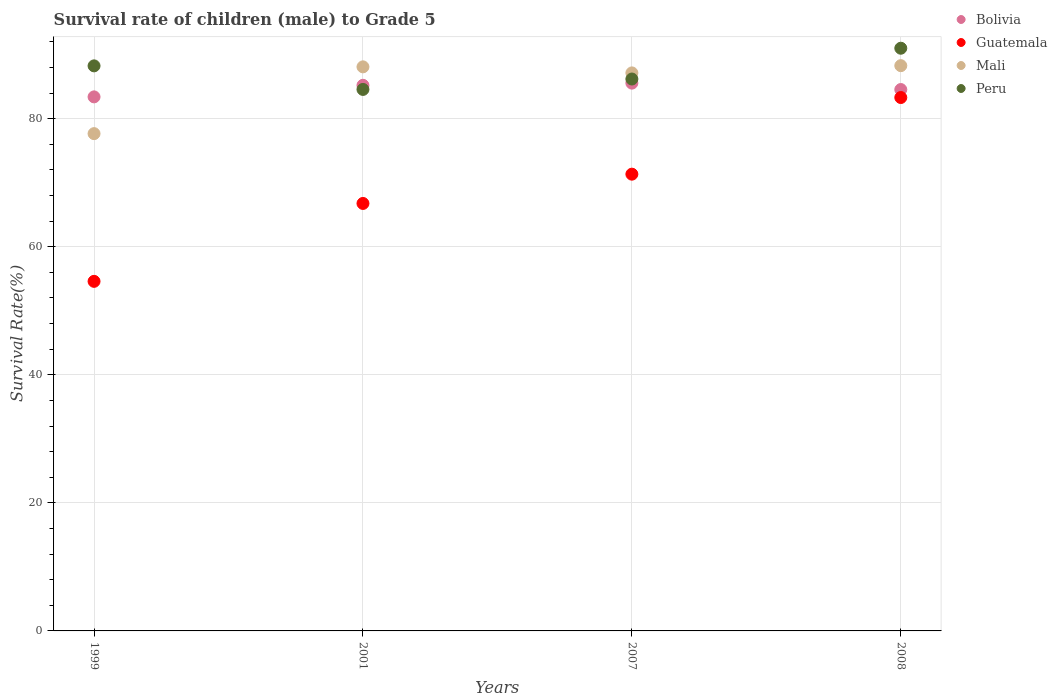Is the number of dotlines equal to the number of legend labels?
Offer a very short reply. Yes. What is the survival rate of male children to grade 5 in Mali in 2007?
Offer a terse response. 87.15. Across all years, what is the maximum survival rate of male children to grade 5 in Mali?
Keep it short and to the point. 88.28. Across all years, what is the minimum survival rate of male children to grade 5 in Mali?
Your answer should be very brief. 77.66. In which year was the survival rate of male children to grade 5 in Guatemala maximum?
Ensure brevity in your answer.  2008. In which year was the survival rate of male children to grade 5 in Mali minimum?
Give a very brief answer. 1999. What is the total survival rate of male children to grade 5 in Peru in the graph?
Provide a succinct answer. 350. What is the difference between the survival rate of male children to grade 5 in Bolivia in 2007 and that in 2008?
Your response must be concise. 1. What is the difference between the survival rate of male children to grade 5 in Bolivia in 2001 and the survival rate of male children to grade 5 in Peru in 2008?
Offer a terse response. -5.79. What is the average survival rate of male children to grade 5 in Mali per year?
Provide a succinct answer. 85.29. In the year 2001, what is the difference between the survival rate of male children to grade 5 in Guatemala and survival rate of male children to grade 5 in Peru?
Provide a short and direct response. -17.8. What is the ratio of the survival rate of male children to grade 5 in Peru in 1999 to that in 2007?
Make the answer very short. 1.02. Is the survival rate of male children to grade 5 in Bolivia in 1999 less than that in 2007?
Keep it short and to the point. Yes. Is the difference between the survival rate of male children to grade 5 in Guatemala in 2001 and 2008 greater than the difference between the survival rate of male children to grade 5 in Peru in 2001 and 2008?
Keep it short and to the point. No. What is the difference between the highest and the second highest survival rate of male children to grade 5 in Guatemala?
Provide a succinct answer. 11.97. What is the difference between the highest and the lowest survival rate of male children to grade 5 in Guatemala?
Offer a terse response. 28.71. Is the sum of the survival rate of male children to grade 5 in Guatemala in 2007 and 2008 greater than the maximum survival rate of male children to grade 5 in Mali across all years?
Give a very brief answer. Yes. Is it the case that in every year, the sum of the survival rate of male children to grade 5 in Guatemala and survival rate of male children to grade 5 in Mali  is greater than the sum of survival rate of male children to grade 5 in Bolivia and survival rate of male children to grade 5 in Peru?
Your answer should be very brief. No. Does the survival rate of male children to grade 5 in Bolivia monotonically increase over the years?
Keep it short and to the point. No. Is the survival rate of male children to grade 5 in Peru strictly greater than the survival rate of male children to grade 5 in Bolivia over the years?
Provide a short and direct response. No. Is the survival rate of male children to grade 5 in Bolivia strictly less than the survival rate of male children to grade 5 in Mali over the years?
Provide a succinct answer. No. How many dotlines are there?
Your answer should be compact. 4. Does the graph contain any zero values?
Offer a very short reply. No. How are the legend labels stacked?
Your answer should be very brief. Vertical. What is the title of the graph?
Your answer should be compact. Survival rate of children (male) to Grade 5. What is the label or title of the X-axis?
Make the answer very short. Years. What is the label or title of the Y-axis?
Your response must be concise. Survival Rate(%). What is the Survival Rate(%) in Bolivia in 1999?
Make the answer very short. 83.4. What is the Survival Rate(%) in Guatemala in 1999?
Ensure brevity in your answer.  54.59. What is the Survival Rate(%) of Mali in 1999?
Provide a succinct answer. 77.66. What is the Survival Rate(%) of Peru in 1999?
Provide a short and direct response. 88.24. What is the Survival Rate(%) of Bolivia in 2001?
Your response must be concise. 85.21. What is the Survival Rate(%) of Guatemala in 2001?
Offer a terse response. 66.76. What is the Survival Rate(%) of Mali in 2001?
Offer a very short reply. 88.09. What is the Survival Rate(%) of Peru in 2001?
Keep it short and to the point. 84.56. What is the Survival Rate(%) in Bolivia in 2007?
Give a very brief answer. 85.55. What is the Survival Rate(%) of Guatemala in 2007?
Your response must be concise. 71.33. What is the Survival Rate(%) of Mali in 2007?
Your answer should be very brief. 87.15. What is the Survival Rate(%) in Peru in 2007?
Offer a terse response. 86.19. What is the Survival Rate(%) of Bolivia in 2008?
Your response must be concise. 84.55. What is the Survival Rate(%) of Guatemala in 2008?
Ensure brevity in your answer.  83.3. What is the Survival Rate(%) of Mali in 2008?
Your answer should be very brief. 88.28. What is the Survival Rate(%) in Peru in 2008?
Ensure brevity in your answer.  91. Across all years, what is the maximum Survival Rate(%) of Bolivia?
Make the answer very short. 85.55. Across all years, what is the maximum Survival Rate(%) of Guatemala?
Your response must be concise. 83.3. Across all years, what is the maximum Survival Rate(%) of Mali?
Your answer should be compact. 88.28. Across all years, what is the maximum Survival Rate(%) in Peru?
Your answer should be compact. 91. Across all years, what is the minimum Survival Rate(%) of Bolivia?
Make the answer very short. 83.4. Across all years, what is the minimum Survival Rate(%) in Guatemala?
Offer a very short reply. 54.59. Across all years, what is the minimum Survival Rate(%) of Mali?
Make the answer very short. 77.66. Across all years, what is the minimum Survival Rate(%) in Peru?
Keep it short and to the point. 84.56. What is the total Survival Rate(%) of Bolivia in the graph?
Provide a succinct answer. 338.71. What is the total Survival Rate(%) of Guatemala in the graph?
Your answer should be very brief. 275.98. What is the total Survival Rate(%) in Mali in the graph?
Provide a short and direct response. 341.17. What is the total Survival Rate(%) of Peru in the graph?
Keep it short and to the point. 350. What is the difference between the Survival Rate(%) of Bolivia in 1999 and that in 2001?
Provide a short and direct response. -1.81. What is the difference between the Survival Rate(%) in Guatemala in 1999 and that in 2001?
Provide a succinct answer. -12.17. What is the difference between the Survival Rate(%) of Mali in 1999 and that in 2001?
Offer a terse response. -10.43. What is the difference between the Survival Rate(%) of Peru in 1999 and that in 2001?
Your answer should be compact. 3.68. What is the difference between the Survival Rate(%) in Bolivia in 1999 and that in 2007?
Make the answer very short. -2.15. What is the difference between the Survival Rate(%) of Guatemala in 1999 and that in 2007?
Offer a very short reply. -16.74. What is the difference between the Survival Rate(%) of Mali in 1999 and that in 2007?
Make the answer very short. -9.48. What is the difference between the Survival Rate(%) in Peru in 1999 and that in 2007?
Provide a short and direct response. 2.05. What is the difference between the Survival Rate(%) of Bolivia in 1999 and that in 2008?
Offer a terse response. -1.15. What is the difference between the Survival Rate(%) of Guatemala in 1999 and that in 2008?
Provide a succinct answer. -28.71. What is the difference between the Survival Rate(%) in Mali in 1999 and that in 2008?
Provide a short and direct response. -10.61. What is the difference between the Survival Rate(%) of Peru in 1999 and that in 2008?
Provide a succinct answer. -2.75. What is the difference between the Survival Rate(%) in Bolivia in 2001 and that in 2007?
Provide a short and direct response. -0.34. What is the difference between the Survival Rate(%) in Guatemala in 2001 and that in 2007?
Your answer should be compact. -4.57. What is the difference between the Survival Rate(%) of Mali in 2001 and that in 2007?
Ensure brevity in your answer.  0.94. What is the difference between the Survival Rate(%) in Peru in 2001 and that in 2007?
Give a very brief answer. -1.63. What is the difference between the Survival Rate(%) in Bolivia in 2001 and that in 2008?
Provide a succinct answer. 0.66. What is the difference between the Survival Rate(%) in Guatemala in 2001 and that in 2008?
Give a very brief answer. -16.54. What is the difference between the Survival Rate(%) in Mali in 2001 and that in 2008?
Your answer should be compact. -0.19. What is the difference between the Survival Rate(%) of Peru in 2001 and that in 2008?
Make the answer very short. -6.43. What is the difference between the Survival Rate(%) in Guatemala in 2007 and that in 2008?
Provide a short and direct response. -11.97. What is the difference between the Survival Rate(%) of Mali in 2007 and that in 2008?
Provide a short and direct response. -1.13. What is the difference between the Survival Rate(%) in Peru in 2007 and that in 2008?
Provide a short and direct response. -4.81. What is the difference between the Survival Rate(%) of Bolivia in 1999 and the Survival Rate(%) of Guatemala in 2001?
Your answer should be compact. 16.64. What is the difference between the Survival Rate(%) of Bolivia in 1999 and the Survival Rate(%) of Mali in 2001?
Your response must be concise. -4.69. What is the difference between the Survival Rate(%) of Bolivia in 1999 and the Survival Rate(%) of Peru in 2001?
Offer a very short reply. -1.16. What is the difference between the Survival Rate(%) of Guatemala in 1999 and the Survival Rate(%) of Mali in 2001?
Ensure brevity in your answer.  -33.5. What is the difference between the Survival Rate(%) of Guatemala in 1999 and the Survival Rate(%) of Peru in 2001?
Offer a terse response. -29.97. What is the difference between the Survival Rate(%) in Mali in 1999 and the Survival Rate(%) in Peru in 2001?
Ensure brevity in your answer.  -6.9. What is the difference between the Survival Rate(%) of Bolivia in 1999 and the Survival Rate(%) of Guatemala in 2007?
Offer a terse response. 12.07. What is the difference between the Survival Rate(%) in Bolivia in 1999 and the Survival Rate(%) in Mali in 2007?
Keep it short and to the point. -3.74. What is the difference between the Survival Rate(%) of Bolivia in 1999 and the Survival Rate(%) of Peru in 2007?
Offer a terse response. -2.79. What is the difference between the Survival Rate(%) in Guatemala in 1999 and the Survival Rate(%) in Mali in 2007?
Give a very brief answer. -32.55. What is the difference between the Survival Rate(%) of Guatemala in 1999 and the Survival Rate(%) of Peru in 2007?
Your answer should be very brief. -31.6. What is the difference between the Survival Rate(%) in Mali in 1999 and the Survival Rate(%) in Peru in 2007?
Offer a very short reply. -8.53. What is the difference between the Survival Rate(%) of Bolivia in 1999 and the Survival Rate(%) of Guatemala in 2008?
Your answer should be very brief. 0.1. What is the difference between the Survival Rate(%) in Bolivia in 1999 and the Survival Rate(%) in Mali in 2008?
Offer a very short reply. -4.87. What is the difference between the Survival Rate(%) of Bolivia in 1999 and the Survival Rate(%) of Peru in 2008?
Your answer should be very brief. -7.6. What is the difference between the Survival Rate(%) in Guatemala in 1999 and the Survival Rate(%) in Mali in 2008?
Give a very brief answer. -33.68. What is the difference between the Survival Rate(%) in Guatemala in 1999 and the Survival Rate(%) in Peru in 2008?
Offer a terse response. -36.41. What is the difference between the Survival Rate(%) in Mali in 1999 and the Survival Rate(%) in Peru in 2008?
Provide a short and direct response. -13.34. What is the difference between the Survival Rate(%) of Bolivia in 2001 and the Survival Rate(%) of Guatemala in 2007?
Your answer should be very brief. 13.88. What is the difference between the Survival Rate(%) in Bolivia in 2001 and the Survival Rate(%) in Mali in 2007?
Provide a succinct answer. -1.94. What is the difference between the Survival Rate(%) in Bolivia in 2001 and the Survival Rate(%) in Peru in 2007?
Offer a very short reply. -0.98. What is the difference between the Survival Rate(%) in Guatemala in 2001 and the Survival Rate(%) in Mali in 2007?
Keep it short and to the point. -20.39. What is the difference between the Survival Rate(%) in Guatemala in 2001 and the Survival Rate(%) in Peru in 2007?
Your response must be concise. -19.43. What is the difference between the Survival Rate(%) of Mali in 2001 and the Survival Rate(%) of Peru in 2007?
Your answer should be compact. 1.9. What is the difference between the Survival Rate(%) in Bolivia in 2001 and the Survival Rate(%) in Guatemala in 2008?
Offer a terse response. 1.91. What is the difference between the Survival Rate(%) of Bolivia in 2001 and the Survival Rate(%) of Mali in 2008?
Keep it short and to the point. -3.07. What is the difference between the Survival Rate(%) of Bolivia in 2001 and the Survival Rate(%) of Peru in 2008?
Make the answer very short. -5.79. What is the difference between the Survival Rate(%) in Guatemala in 2001 and the Survival Rate(%) in Mali in 2008?
Offer a terse response. -21.52. What is the difference between the Survival Rate(%) of Guatemala in 2001 and the Survival Rate(%) of Peru in 2008?
Your answer should be compact. -24.24. What is the difference between the Survival Rate(%) of Mali in 2001 and the Survival Rate(%) of Peru in 2008?
Offer a very short reply. -2.91. What is the difference between the Survival Rate(%) of Bolivia in 2007 and the Survival Rate(%) of Guatemala in 2008?
Your answer should be very brief. 2.25. What is the difference between the Survival Rate(%) in Bolivia in 2007 and the Survival Rate(%) in Mali in 2008?
Your answer should be compact. -2.73. What is the difference between the Survival Rate(%) in Bolivia in 2007 and the Survival Rate(%) in Peru in 2008?
Make the answer very short. -5.45. What is the difference between the Survival Rate(%) in Guatemala in 2007 and the Survival Rate(%) in Mali in 2008?
Your answer should be very brief. -16.94. What is the difference between the Survival Rate(%) of Guatemala in 2007 and the Survival Rate(%) of Peru in 2008?
Your answer should be very brief. -19.67. What is the difference between the Survival Rate(%) of Mali in 2007 and the Survival Rate(%) of Peru in 2008?
Make the answer very short. -3.85. What is the average Survival Rate(%) of Bolivia per year?
Offer a very short reply. 84.68. What is the average Survival Rate(%) of Guatemala per year?
Your response must be concise. 69. What is the average Survival Rate(%) in Mali per year?
Your response must be concise. 85.29. What is the average Survival Rate(%) of Peru per year?
Offer a very short reply. 87.5. In the year 1999, what is the difference between the Survival Rate(%) of Bolivia and Survival Rate(%) of Guatemala?
Ensure brevity in your answer.  28.81. In the year 1999, what is the difference between the Survival Rate(%) of Bolivia and Survival Rate(%) of Mali?
Ensure brevity in your answer.  5.74. In the year 1999, what is the difference between the Survival Rate(%) in Bolivia and Survival Rate(%) in Peru?
Your answer should be compact. -4.84. In the year 1999, what is the difference between the Survival Rate(%) of Guatemala and Survival Rate(%) of Mali?
Your answer should be compact. -23.07. In the year 1999, what is the difference between the Survival Rate(%) in Guatemala and Survival Rate(%) in Peru?
Ensure brevity in your answer.  -33.65. In the year 1999, what is the difference between the Survival Rate(%) in Mali and Survival Rate(%) in Peru?
Ensure brevity in your answer.  -10.58. In the year 2001, what is the difference between the Survival Rate(%) in Bolivia and Survival Rate(%) in Guatemala?
Your answer should be compact. 18.45. In the year 2001, what is the difference between the Survival Rate(%) in Bolivia and Survival Rate(%) in Mali?
Give a very brief answer. -2.88. In the year 2001, what is the difference between the Survival Rate(%) of Bolivia and Survival Rate(%) of Peru?
Make the answer very short. 0.64. In the year 2001, what is the difference between the Survival Rate(%) of Guatemala and Survival Rate(%) of Mali?
Provide a succinct answer. -21.33. In the year 2001, what is the difference between the Survival Rate(%) in Guatemala and Survival Rate(%) in Peru?
Keep it short and to the point. -17.8. In the year 2001, what is the difference between the Survival Rate(%) in Mali and Survival Rate(%) in Peru?
Your response must be concise. 3.53. In the year 2007, what is the difference between the Survival Rate(%) in Bolivia and Survival Rate(%) in Guatemala?
Offer a terse response. 14.22. In the year 2007, what is the difference between the Survival Rate(%) of Bolivia and Survival Rate(%) of Mali?
Provide a succinct answer. -1.6. In the year 2007, what is the difference between the Survival Rate(%) in Bolivia and Survival Rate(%) in Peru?
Keep it short and to the point. -0.64. In the year 2007, what is the difference between the Survival Rate(%) of Guatemala and Survival Rate(%) of Mali?
Offer a very short reply. -15.81. In the year 2007, what is the difference between the Survival Rate(%) in Guatemala and Survival Rate(%) in Peru?
Keep it short and to the point. -14.86. In the year 2007, what is the difference between the Survival Rate(%) in Mali and Survival Rate(%) in Peru?
Your answer should be very brief. 0.96. In the year 2008, what is the difference between the Survival Rate(%) of Bolivia and Survival Rate(%) of Guatemala?
Make the answer very short. 1.25. In the year 2008, what is the difference between the Survival Rate(%) of Bolivia and Survival Rate(%) of Mali?
Your response must be concise. -3.73. In the year 2008, what is the difference between the Survival Rate(%) of Bolivia and Survival Rate(%) of Peru?
Offer a terse response. -6.45. In the year 2008, what is the difference between the Survival Rate(%) in Guatemala and Survival Rate(%) in Mali?
Offer a very short reply. -4.98. In the year 2008, what is the difference between the Survival Rate(%) in Guatemala and Survival Rate(%) in Peru?
Offer a very short reply. -7.7. In the year 2008, what is the difference between the Survival Rate(%) of Mali and Survival Rate(%) of Peru?
Provide a succinct answer. -2.72. What is the ratio of the Survival Rate(%) in Bolivia in 1999 to that in 2001?
Give a very brief answer. 0.98. What is the ratio of the Survival Rate(%) of Guatemala in 1999 to that in 2001?
Make the answer very short. 0.82. What is the ratio of the Survival Rate(%) in Mali in 1999 to that in 2001?
Your answer should be compact. 0.88. What is the ratio of the Survival Rate(%) in Peru in 1999 to that in 2001?
Provide a succinct answer. 1.04. What is the ratio of the Survival Rate(%) of Bolivia in 1999 to that in 2007?
Offer a terse response. 0.97. What is the ratio of the Survival Rate(%) of Guatemala in 1999 to that in 2007?
Provide a succinct answer. 0.77. What is the ratio of the Survival Rate(%) of Mali in 1999 to that in 2007?
Offer a terse response. 0.89. What is the ratio of the Survival Rate(%) in Peru in 1999 to that in 2007?
Give a very brief answer. 1.02. What is the ratio of the Survival Rate(%) of Bolivia in 1999 to that in 2008?
Provide a succinct answer. 0.99. What is the ratio of the Survival Rate(%) in Guatemala in 1999 to that in 2008?
Offer a terse response. 0.66. What is the ratio of the Survival Rate(%) of Mali in 1999 to that in 2008?
Offer a terse response. 0.88. What is the ratio of the Survival Rate(%) of Peru in 1999 to that in 2008?
Keep it short and to the point. 0.97. What is the ratio of the Survival Rate(%) in Guatemala in 2001 to that in 2007?
Provide a short and direct response. 0.94. What is the ratio of the Survival Rate(%) in Mali in 2001 to that in 2007?
Provide a short and direct response. 1.01. What is the ratio of the Survival Rate(%) of Peru in 2001 to that in 2007?
Offer a terse response. 0.98. What is the ratio of the Survival Rate(%) of Guatemala in 2001 to that in 2008?
Give a very brief answer. 0.8. What is the ratio of the Survival Rate(%) of Mali in 2001 to that in 2008?
Provide a succinct answer. 1. What is the ratio of the Survival Rate(%) in Peru in 2001 to that in 2008?
Your answer should be compact. 0.93. What is the ratio of the Survival Rate(%) of Bolivia in 2007 to that in 2008?
Offer a very short reply. 1.01. What is the ratio of the Survival Rate(%) in Guatemala in 2007 to that in 2008?
Your answer should be very brief. 0.86. What is the ratio of the Survival Rate(%) of Mali in 2007 to that in 2008?
Offer a very short reply. 0.99. What is the ratio of the Survival Rate(%) of Peru in 2007 to that in 2008?
Give a very brief answer. 0.95. What is the difference between the highest and the second highest Survival Rate(%) of Bolivia?
Offer a very short reply. 0.34. What is the difference between the highest and the second highest Survival Rate(%) in Guatemala?
Give a very brief answer. 11.97. What is the difference between the highest and the second highest Survival Rate(%) in Mali?
Offer a terse response. 0.19. What is the difference between the highest and the second highest Survival Rate(%) of Peru?
Your response must be concise. 2.75. What is the difference between the highest and the lowest Survival Rate(%) in Bolivia?
Provide a short and direct response. 2.15. What is the difference between the highest and the lowest Survival Rate(%) of Guatemala?
Your response must be concise. 28.71. What is the difference between the highest and the lowest Survival Rate(%) of Mali?
Provide a succinct answer. 10.61. What is the difference between the highest and the lowest Survival Rate(%) of Peru?
Offer a terse response. 6.43. 